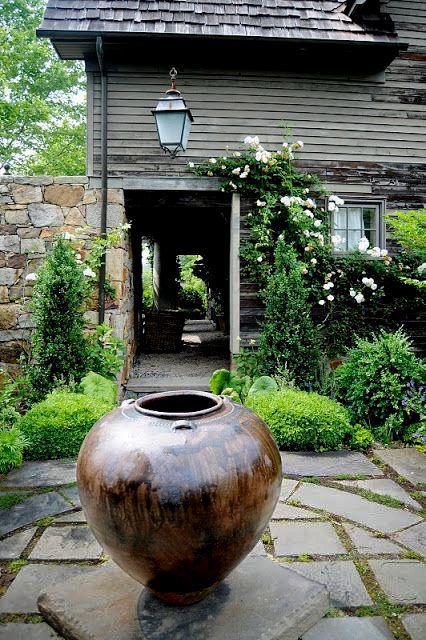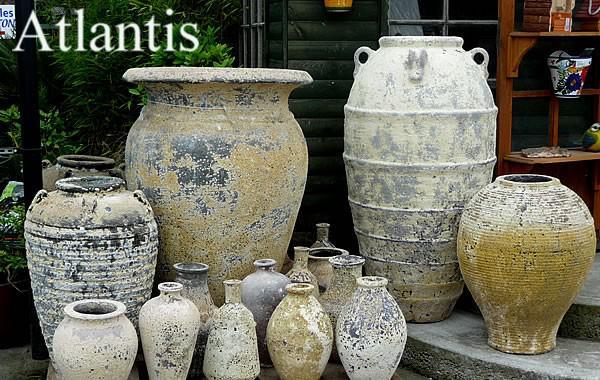The first image is the image on the left, the second image is the image on the right. Considering the images on both sides, is "There are no more than three urns." valid? Answer yes or no. No. The first image is the image on the left, the second image is the image on the right. Considering the images on both sides, is "All planters are grey stone-look material and sit on square pedestal bases, and at least one planter holds a plant," valid? Answer yes or no. No. 